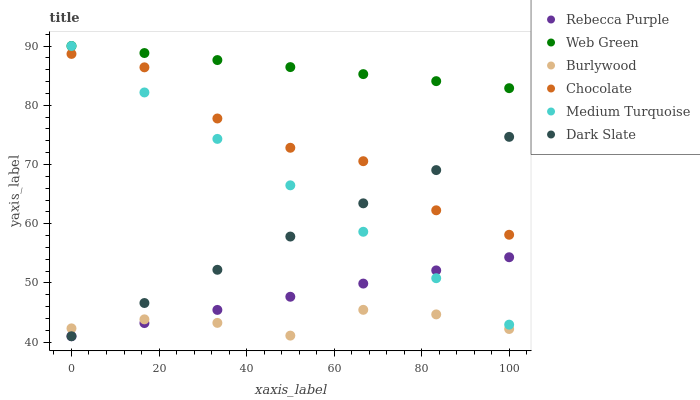Does Burlywood have the minimum area under the curve?
Answer yes or no. Yes. Does Web Green have the maximum area under the curve?
Answer yes or no. Yes. Does Chocolate have the minimum area under the curve?
Answer yes or no. No. Does Chocolate have the maximum area under the curve?
Answer yes or no. No. Is Rebecca Purple the smoothest?
Answer yes or no. Yes. Is Chocolate the roughest?
Answer yes or no. Yes. Is Web Green the smoothest?
Answer yes or no. No. Is Web Green the roughest?
Answer yes or no. No. Does Dark Slate have the lowest value?
Answer yes or no. Yes. Does Chocolate have the lowest value?
Answer yes or no. No. Does Medium Turquoise have the highest value?
Answer yes or no. Yes. Does Chocolate have the highest value?
Answer yes or no. No. Is Burlywood less than Web Green?
Answer yes or no. Yes. Is Web Green greater than Burlywood?
Answer yes or no. Yes. Does Rebecca Purple intersect Dark Slate?
Answer yes or no. Yes. Is Rebecca Purple less than Dark Slate?
Answer yes or no. No. Is Rebecca Purple greater than Dark Slate?
Answer yes or no. No. Does Burlywood intersect Web Green?
Answer yes or no. No. 